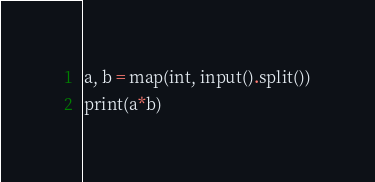Convert code to text. <code><loc_0><loc_0><loc_500><loc_500><_Python_>a, b = map(int, input().split())
print(a*b)</code> 